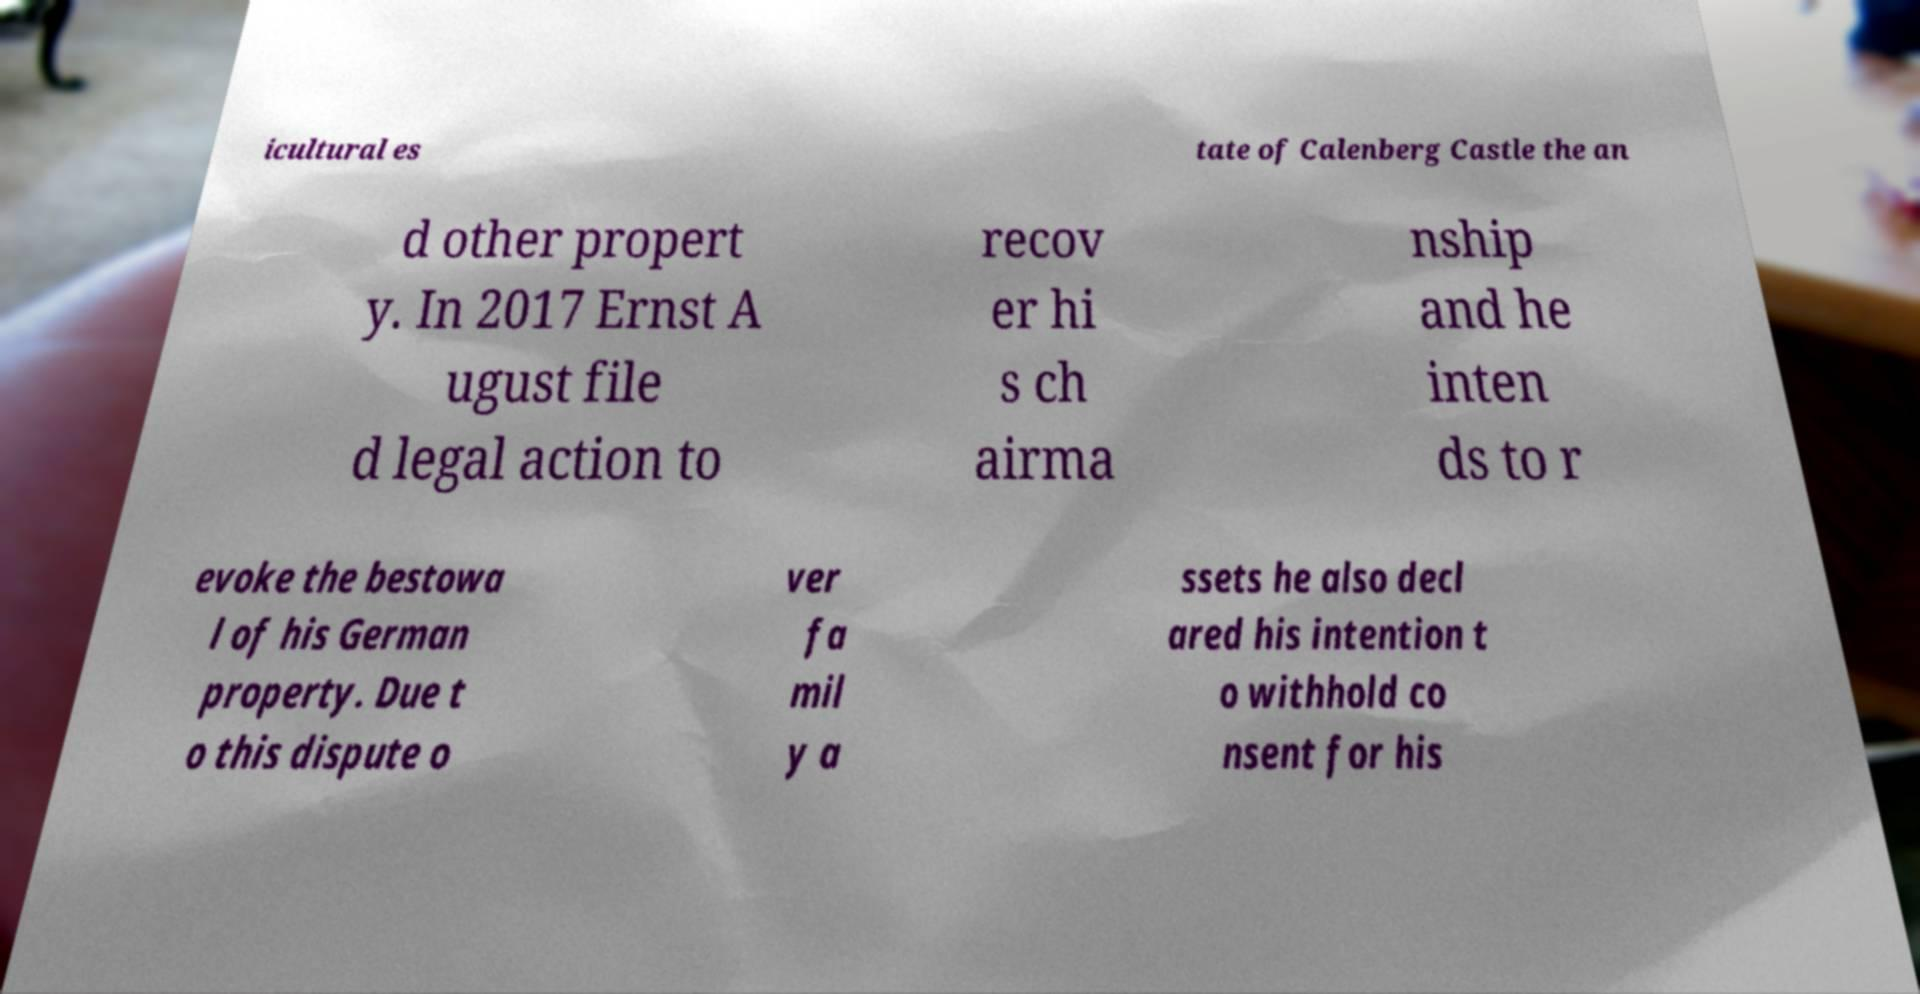I need the written content from this picture converted into text. Can you do that? icultural es tate of Calenberg Castle the an d other propert y. In 2017 Ernst A ugust file d legal action to recov er hi s ch airma nship and he inten ds to r evoke the bestowa l of his German property. Due t o this dispute o ver fa mil y a ssets he also decl ared his intention t o withhold co nsent for his 